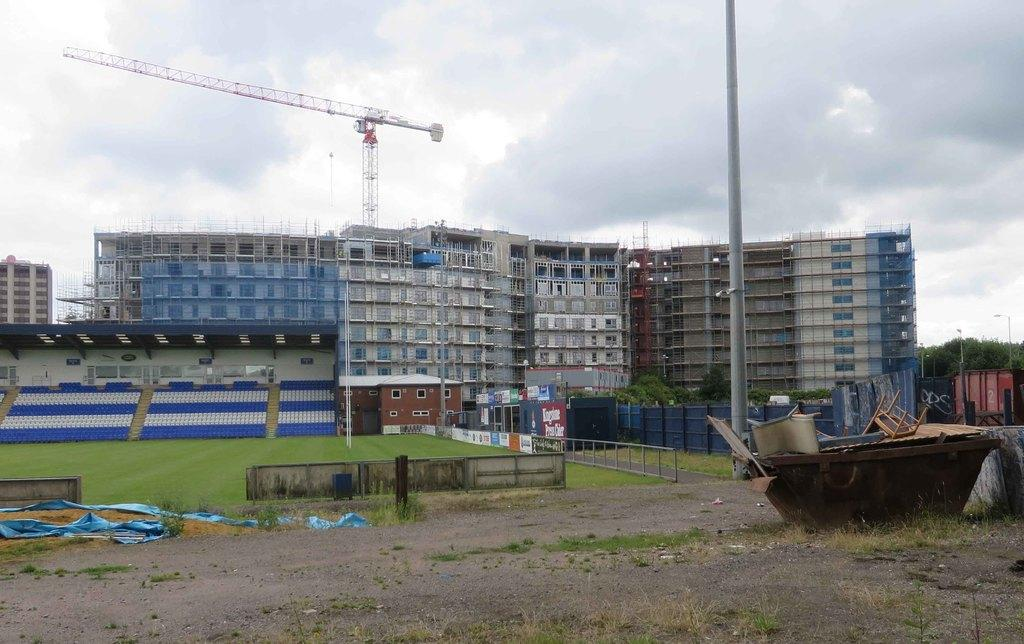What type of furniture is present in the image? There is a chair in the image. What structures can be seen in the image? There are poles and buildings with windows in the image. What architectural feature is present in the image? There is a fence in the image. What decorative elements are present in the image? There are banners in the image. What type of vegetation is visible in the image? There is grass in the image. What can be seen in the background of the image? The sky with clouds is visible in the background of the image. Where is the harbor located in the image? There is no harbor present in the image. What type of writing instrument is being used by the person in the image? There is no person or writing instrument present in the image. 